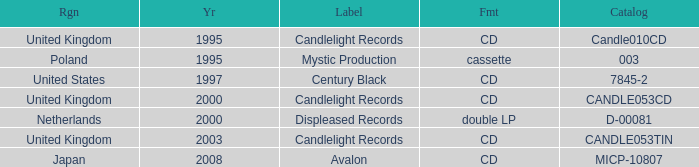What year did Japan form a label? 2008.0. 